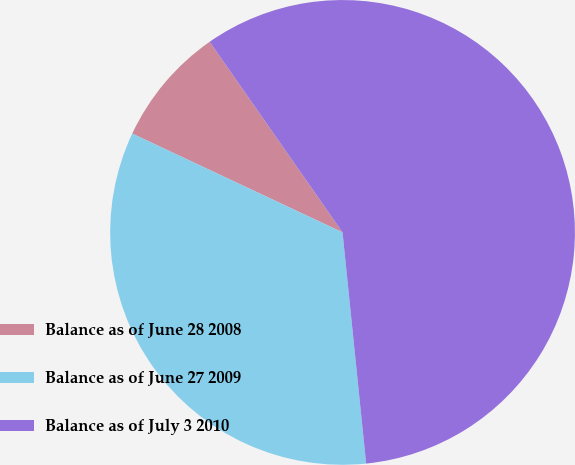<chart> <loc_0><loc_0><loc_500><loc_500><pie_chart><fcel>Balance as of June 28 2008<fcel>Balance as of June 27 2009<fcel>Balance as of July 3 2010<nl><fcel>8.32%<fcel>33.61%<fcel>58.07%<nl></chart> 